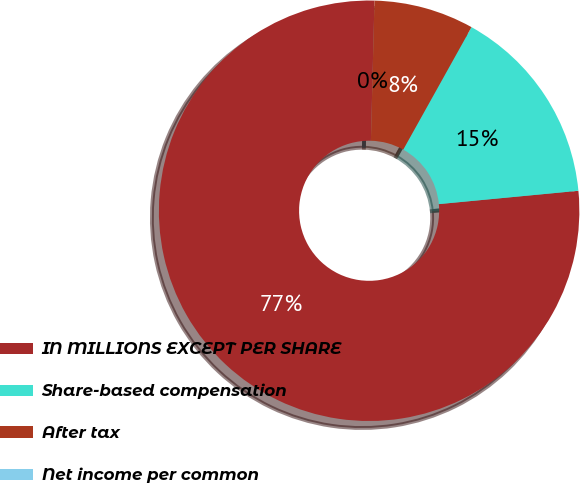Convert chart to OTSL. <chart><loc_0><loc_0><loc_500><loc_500><pie_chart><fcel>IN MILLIONS EXCEPT PER SHARE<fcel>Share-based compensation<fcel>After tax<fcel>Net income per common<nl><fcel>76.92%<fcel>15.39%<fcel>7.69%<fcel>0.0%<nl></chart> 